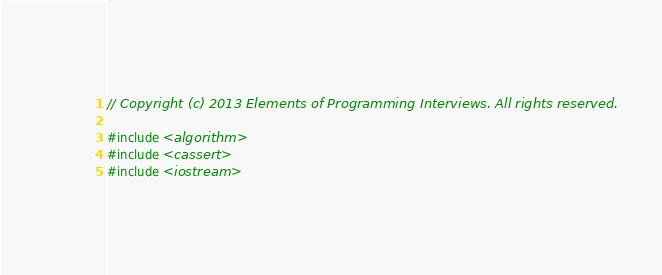Convert code to text. <code><loc_0><loc_0><loc_500><loc_500><_C++_>// Copyright (c) 2013 Elements of Programming Interviews. All rights reserved.

#include <algorithm>
#include <cassert>
#include <iostream></code> 